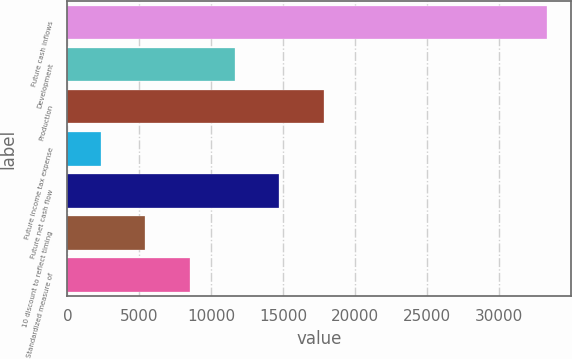<chart> <loc_0><loc_0><loc_500><loc_500><bar_chart><fcel>Future cash inflows<fcel>Development<fcel>Production<fcel>Future income tax expense<fcel>Future net cash flow<fcel>10 discount to reflect timing<fcel>Standardized measure of<nl><fcel>33305<fcel>11620.4<fcel>17816<fcel>2327<fcel>14718.2<fcel>5424.8<fcel>8522.6<nl></chart> 